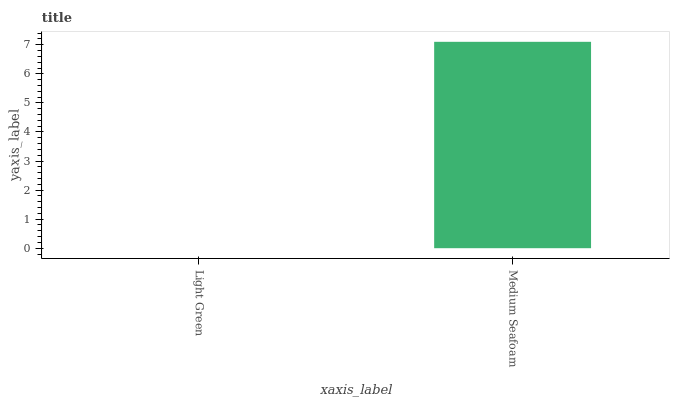Is Light Green the minimum?
Answer yes or no. Yes. Is Medium Seafoam the maximum?
Answer yes or no. Yes. Is Medium Seafoam the minimum?
Answer yes or no. No. Is Medium Seafoam greater than Light Green?
Answer yes or no. Yes. Is Light Green less than Medium Seafoam?
Answer yes or no. Yes. Is Light Green greater than Medium Seafoam?
Answer yes or no. No. Is Medium Seafoam less than Light Green?
Answer yes or no. No. Is Medium Seafoam the high median?
Answer yes or no. Yes. Is Light Green the low median?
Answer yes or no. Yes. Is Light Green the high median?
Answer yes or no. No. Is Medium Seafoam the low median?
Answer yes or no. No. 